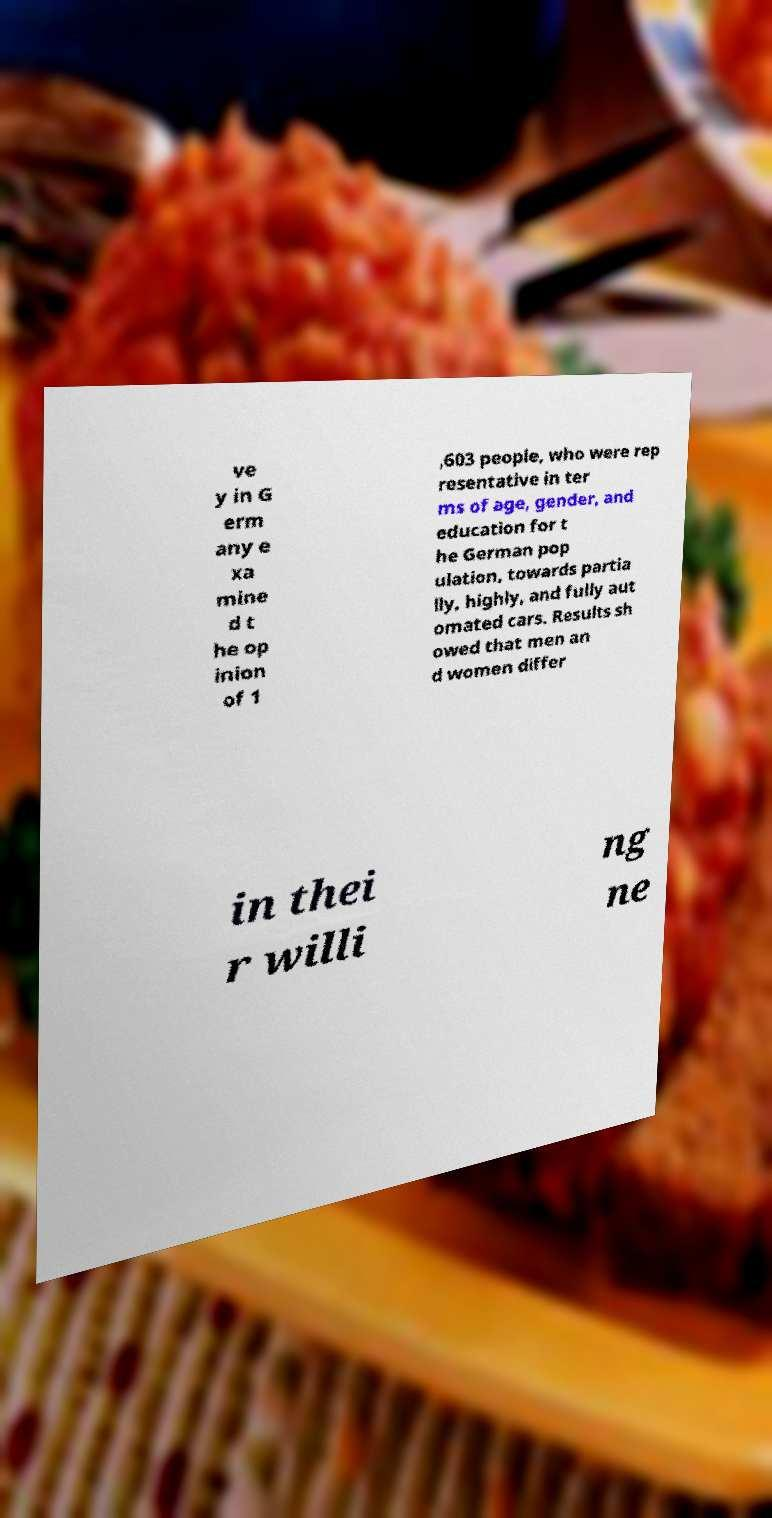Please identify and transcribe the text found in this image. ve y in G erm any e xa mine d t he op inion of 1 ,603 people, who were rep resentative in ter ms of age, gender, and education for t he German pop ulation, towards partia lly, highly, and fully aut omated cars. Results sh owed that men an d women differ in thei r willi ng ne 